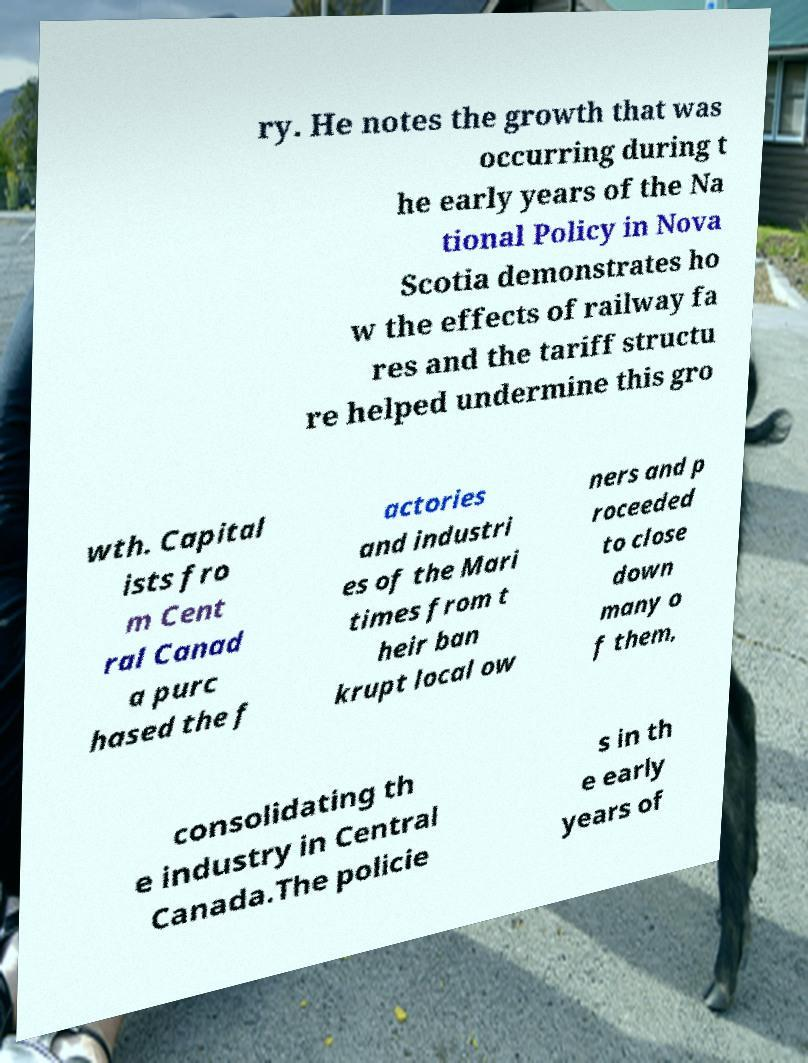What messages or text are displayed in this image? I need them in a readable, typed format. ry. He notes the growth that was occurring during t he early years of the Na tional Policy in Nova Scotia demonstrates ho w the effects of railway fa res and the tariff structu re helped undermine this gro wth. Capital ists fro m Cent ral Canad a purc hased the f actories and industri es of the Mari times from t heir ban krupt local ow ners and p roceeded to close down many o f them, consolidating th e industry in Central Canada.The policie s in th e early years of 